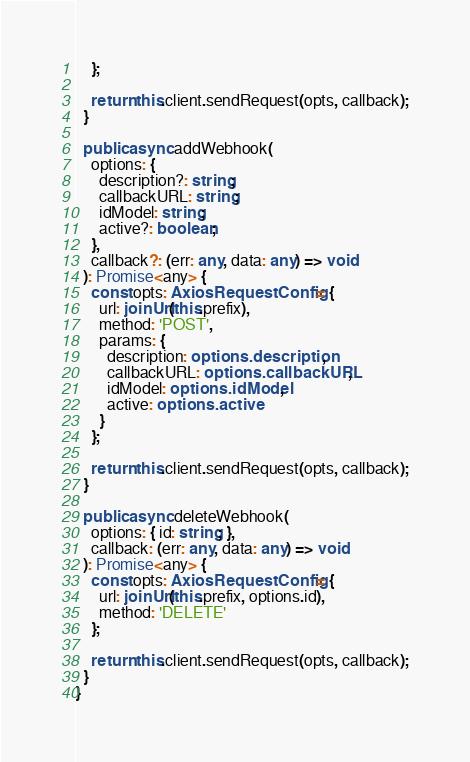Convert code to text. <code><loc_0><loc_0><loc_500><loc_500><_TypeScript_>    };

    return this.client.sendRequest(opts, callback);
  }

  public async addWebhook(
    options: {
      description?: string;
      callbackURL: string;
      idModel: string;
      active?: boolean;
    },
    callback?: (err: any, data: any) => void
  ): Promise<any> {
    const opts: AxiosRequestConfig = {
      url: joinUrl(this.prefix),
      method: 'POST',
      params: {
        description: options.description,
        callbackURL: options.callbackURL,
        idModel: options.idModel,
        active: options.active
      }
    };

    return this.client.sendRequest(opts, callback);
  }

  public async deleteWebhook(
    options: { id: string; },
    callback: (err: any, data: any) => void
  ): Promise<any> {
    const opts: AxiosRequestConfig = {
      url: joinUrl(this.prefix, options.id),
      method: 'DELETE'
    };

    return this.client.sendRequest(opts, callback);
  }
}
</code> 